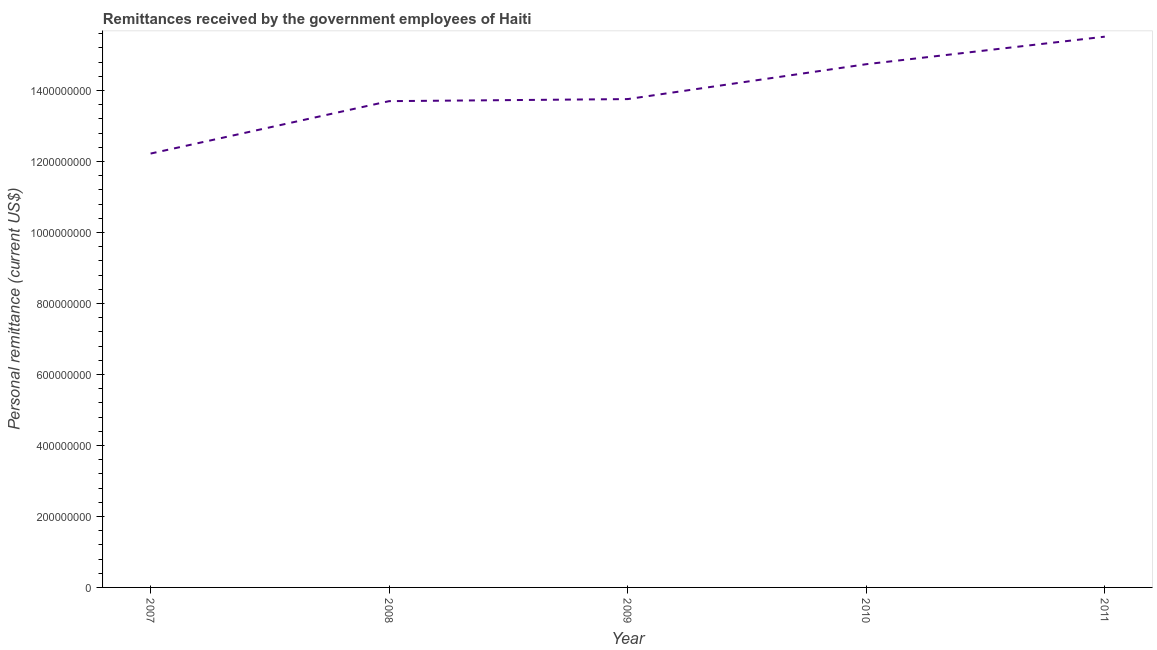What is the personal remittances in 2008?
Keep it short and to the point. 1.37e+09. Across all years, what is the maximum personal remittances?
Offer a terse response. 1.55e+09. Across all years, what is the minimum personal remittances?
Ensure brevity in your answer.  1.22e+09. What is the sum of the personal remittances?
Keep it short and to the point. 6.99e+09. What is the difference between the personal remittances in 2008 and 2010?
Provide a short and direct response. -1.04e+08. What is the average personal remittances per year?
Offer a very short reply. 1.40e+09. What is the median personal remittances?
Make the answer very short. 1.38e+09. Do a majority of the years between 2009 and 2011 (inclusive) have personal remittances greater than 840000000 US$?
Make the answer very short. Yes. What is the ratio of the personal remittances in 2009 to that in 2011?
Your answer should be compact. 0.89. Is the personal remittances in 2009 less than that in 2010?
Provide a short and direct response. Yes. What is the difference between the highest and the second highest personal remittances?
Keep it short and to the point. 7.76e+07. Is the sum of the personal remittances in 2007 and 2009 greater than the maximum personal remittances across all years?
Your answer should be compact. Yes. What is the difference between the highest and the lowest personal remittances?
Your response must be concise. 3.29e+08. In how many years, is the personal remittances greater than the average personal remittances taken over all years?
Offer a very short reply. 2. How many lines are there?
Make the answer very short. 1. How many years are there in the graph?
Provide a short and direct response. 5. What is the title of the graph?
Provide a short and direct response. Remittances received by the government employees of Haiti. What is the label or title of the Y-axis?
Give a very brief answer. Personal remittance (current US$). What is the Personal remittance (current US$) of 2007?
Your response must be concise. 1.22e+09. What is the Personal remittance (current US$) of 2008?
Give a very brief answer. 1.37e+09. What is the Personal remittance (current US$) in 2009?
Keep it short and to the point. 1.38e+09. What is the Personal remittance (current US$) in 2010?
Offer a terse response. 1.47e+09. What is the Personal remittance (current US$) of 2011?
Provide a short and direct response. 1.55e+09. What is the difference between the Personal remittance (current US$) in 2007 and 2008?
Your answer should be compact. -1.48e+08. What is the difference between the Personal remittance (current US$) in 2007 and 2009?
Your answer should be compact. -1.53e+08. What is the difference between the Personal remittance (current US$) in 2007 and 2010?
Your answer should be compact. -2.52e+08. What is the difference between the Personal remittance (current US$) in 2007 and 2011?
Offer a very short reply. -3.29e+08. What is the difference between the Personal remittance (current US$) in 2008 and 2009?
Your answer should be very brief. -5.79e+06. What is the difference between the Personal remittance (current US$) in 2008 and 2010?
Provide a succinct answer. -1.04e+08. What is the difference between the Personal remittance (current US$) in 2008 and 2011?
Provide a short and direct response. -1.82e+08. What is the difference between the Personal remittance (current US$) in 2009 and 2010?
Offer a very short reply. -9.83e+07. What is the difference between the Personal remittance (current US$) in 2009 and 2011?
Ensure brevity in your answer.  -1.76e+08. What is the difference between the Personal remittance (current US$) in 2010 and 2011?
Your answer should be very brief. -7.76e+07. What is the ratio of the Personal remittance (current US$) in 2007 to that in 2008?
Provide a succinct answer. 0.89. What is the ratio of the Personal remittance (current US$) in 2007 to that in 2009?
Keep it short and to the point. 0.89. What is the ratio of the Personal remittance (current US$) in 2007 to that in 2010?
Your response must be concise. 0.83. What is the ratio of the Personal remittance (current US$) in 2007 to that in 2011?
Offer a very short reply. 0.79. What is the ratio of the Personal remittance (current US$) in 2008 to that in 2009?
Ensure brevity in your answer.  1. What is the ratio of the Personal remittance (current US$) in 2008 to that in 2010?
Keep it short and to the point. 0.93. What is the ratio of the Personal remittance (current US$) in 2008 to that in 2011?
Make the answer very short. 0.88. What is the ratio of the Personal remittance (current US$) in 2009 to that in 2010?
Provide a succinct answer. 0.93. What is the ratio of the Personal remittance (current US$) in 2009 to that in 2011?
Offer a very short reply. 0.89. What is the ratio of the Personal remittance (current US$) in 2010 to that in 2011?
Ensure brevity in your answer.  0.95. 